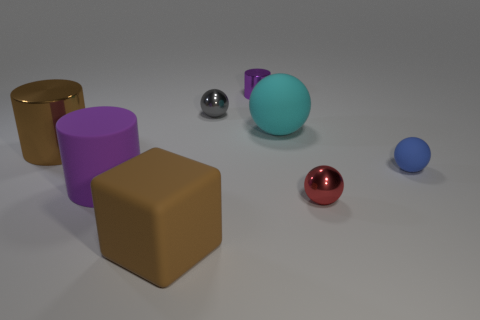Can you compare the sizes of the two largest objects in the image for me? Certainly! The largest object appears to be the cyan-colored sphere; it is significantly larger than the golden cylinder, which is the second-largest object in the scene. 